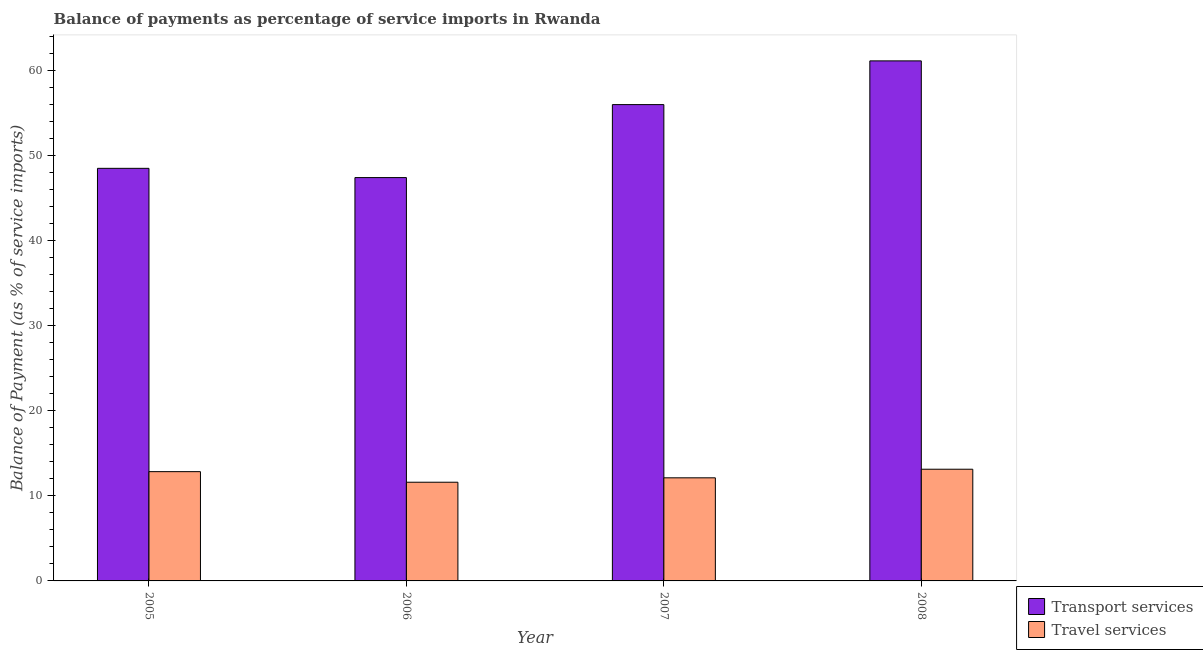How many groups of bars are there?
Ensure brevity in your answer.  4. Are the number of bars per tick equal to the number of legend labels?
Keep it short and to the point. Yes. Are the number of bars on each tick of the X-axis equal?
Give a very brief answer. Yes. How many bars are there on the 3rd tick from the right?
Ensure brevity in your answer.  2. In how many cases, is the number of bars for a given year not equal to the number of legend labels?
Make the answer very short. 0. What is the balance of payments of transport services in 2007?
Offer a terse response. 55.98. Across all years, what is the maximum balance of payments of transport services?
Offer a terse response. 61.11. Across all years, what is the minimum balance of payments of transport services?
Keep it short and to the point. 47.4. In which year was the balance of payments of transport services minimum?
Make the answer very short. 2006. What is the total balance of payments of transport services in the graph?
Offer a terse response. 212.97. What is the difference between the balance of payments of transport services in 2006 and that in 2007?
Your answer should be very brief. -8.58. What is the difference between the balance of payments of transport services in 2005 and the balance of payments of travel services in 2008?
Your answer should be compact. -12.63. What is the average balance of payments of travel services per year?
Provide a succinct answer. 12.42. In how many years, is the balance of payments of travel services greater than 20 %?
Provide a succinct answer. 0. What is the ratio of the balance of payments of transport services in 2005 to that in 2008?
Provide a short and direct response. 0.79. What is the difference between the highest and the second highest balance of payments of transport services?
Offer a terse response. 5.14. What is the difference between the highest and the lowest balance of payments of travel services?
Ensure brevity in your answer.  1.53. What does the 1st bar from the left in 2006 represents?
Make the answer very short. Transport services. What does the 1st bar from the right in 2007 represents?
Your answer should be compact. Travel services. What is the difference between two consecutive major ticks on the Y-axis?
Your answer should be compact. 10. Are the values on the major ticks of Y-axis written in scientific E-notation?
Give a very brief answer. No. What is the title of the graph?
Your answer should be compact. Balance of payments as percentage of service imports in Rwanda. Does "Revenue" appear as one of the legend labels in the graph?
Provide a succinct answer. No. What is the label or title of the X-axis?
Give a very brief answer. Year. What is the label or title of the Y-axis?
Provide a succinct answer. Balance of Payment (as % of service imports). What is the Balance of Payment (as % of service imports) of Transport services in 2005?
Ensure brevity in your answer.  48.49. What is the Balance of Payment (as % of service imports) of Travel services in 2005?
Your response must be concise. 12.84. What is the Balance of Payment (as % of service imports) in Transport services in 2006?
Give a very brief answer. 47.4. What is the Balance of Payment (as % of service imports) in Travel services in 2006?
Your response must be concise. 11.6. What is the Balance of Payment (as % of service imports) in Transport services in 2007?
Offer a terse response. 55.98. What is the Balance of Payment (as % of service imports) of Travel services in 2007?
Provide a short and direct response. 12.12. What is the Balance of Payment (as % of service imports) of Transport services in 2008?
Offer a very short reply. 61.11. What is the Balance of Payment (as % of service imports) of Travel services in 2008?
Your answer should be compact. 13.13. Across all years, what is the maximum Balance of Payment (as % of service imports) of Transport services?
Make the answer very short. 61.11. Across all years, what is the maximum Balance of Payment (as % of service imports) of Travel services?
Provide a succinct answer. 13.13. Across all years, what is the minimum Balance of Payment (as % of service imports) in Transport services?
Provide a succinct answer. 47.4. Across all years, what is the minimum Balance of Payment (as % of service imports) of Travel services?
Offer a terse response. 11.6. What is the total Balance of Payment (as % of service imports) of Transport services in the graph?
Keep it short and to the point. 212.97. What is the total Balance of Payment (as % of service imports) of Travel services in the graph?
Offer a very short reply. 49.68. What is the difference between the Balance of Payment (as % of service imports) in Transport services in 2005 and that in 2006?
Provide a short and direct response. 1.09. What is the difference between the Balance of Payment (as % of service imports) in Travel services in 2005 and that in 2006?
Make the answer very short. 1.24. What is the difference between the Balance of Payment (as % of service imports) of Transport services in 2005 and that in 2007?
Your response must be concise. -7.49. What is the difference between the Balance of Payment (as % of service imports) of Travel services in 2005 and that in 2007?
Make the answer very short. 0.73. What is the difference between the Balance of Payment (as % of service imports) of Transport services in 2005 and that in 2008?
Offer a very short reply. -12.63. What is the difference between the Balance of Payment (as % of service imports) in Travel services in 2005 and that in 2008?
Your answer should be compact. -0.28. What is the difference between the Balance of Payment (as % of service imports) of Transport services in 2006 and that in 2007?
Your answer should be compact. -8.58. What is the difference between the Balance of Payment (as % of service imports) of Travel services in 2006 and that in 2007?
Ensure brevity in your answer.  -0.52. What is the difference between the Balance of Payment (as % of service imports) in Transport services in 2006 and that in 2008?
Ensure brevity in your answer.  -13.72. What is the difference between the Balance of Payment (as % of service imports) in Travel services in 2006 and that in 2008?
Your answer should be compact. -1.53. What is the difference between the Balance of Payment (as % of service imports) of Transport services in 2007 and that in 2008?
Give a very brief answer. -5.14. What is the difference between the Balance of Payment (as % of service imports) in Travel services in 2007 and that in 2008?
Ensure brevity in your answer.  -1.01. What is the difference between the Balance of Payment (as % of service imports) of Transport services in 2005 and the Balance of Payment (as % of service imports) of Travel services in 2006?
Your answer should be compact. 36.89. What is the difference between the Balance of Payment (as % of service imports) in Transport services in 2005 and the Balance of Payment (as % of service imports) in Travel services in 2007?
Provide a succinct answer. 36.37. What is the difference between the Balance of Payment (as % of service imports) in Transport services in 2005 and the Balance of Payment (as % of service imports) in Travel services in 2008?
Provide a succinct answer. 35.36. What is the difference between the Balance of Payment (as % of service imports) of Transport services in 2006 and the Balance of Payment (as % of service imports) of Travel services in 2007?
Your response must be concise. 35.28. What is the difference between the Balance of Payment (as % of service imports) of Transport services in 2006 and the Balance of Payment (as % of service imports) of Travel services in 2008?
Keep it short and to the point. 34.27. What is the difference between the Balance of Payment (as % of service imports) of Transport services in 2007 and the Balance of Payment (as % of service imports) of Travel services in 2008?
Offer a very short reply. 42.85. What is the average Balance of Payment (as % of service imports) in Transport services per year?
Give a very brief answer. 53.24. What is the average Balance of Payment (as % of service imports) in Travel services per year?
Ensure brevity in your answer.  12.42. In the year 2005, what is the difference between the Balance of Payment (as % of service imports) of Transport services and Balance of Payment (as % of service imports) of Travel services?
Provide a short and direct response. 35.64. In the year 2006, what is the difference between the Balance of Payment (as % of service imports) in Transport services and Balance of Payment (as % of service imports) in Travel services?
Provide a short and direct response. 35.8. In the year 2007, what is the difference between the Balance of Payment (as % of service imports) in Transport services and Balance of Payment (as % of service imports) in Travel services?
Your answer should be compact. 43.86. In the year 2008, what is the difference between the Balance of Payment (as % of service imports) of Transport services and Balance of Payment (as % of service imports) of Travel services?
Offer a terse response. 47.99. What is the ratio of the Balance of Payment (as % of service imports) in Transport services in 2005 to that in 2006?
Make the answer very short. 1.02. What is the ratio of the Balance of Payment (as % of service imports) of Travel services in 2005 to that in 2006?
Give a very brief answer. 1.11. What is the ratio of the Balance of Payment (as % of service imports) of Transport services in 2005 to that in 2007?
Your answer should be compact. 0.87. What is the ratio of the Balance of Payment (as % of service imports) of Travel services in 2005 to that in 2007?
Your answer should be very brief. 1.06. What is the ratio of the Balance of Payment (as % of service imports) in Transport services in 2005 to that in 2008?
Offer a terse response. 0.79. What is the ratio of the Balance of Payment (as % of service imports) in Travel services in 2005 to that in 2008?
Ensure brevity in your answer.  0.98. What is the ratio of the Balance of Payment (as % of service imports) of Transport services in 2006 to that in 2007?
Your response must be concise. 0.85. What is the ratio of the Balance of Payment (as % of service imports) in Travel services in 2006 to that in 2007?
Give a very brief answer. 0.96. What is the ratio of the Balance of Payment (as % of service imports) of Transport services in 2006 to that in 2008?
Give a very brief answer. 0.78. What is the ratio of the Balance of Payment (as % of service imports) of Travel services in 2006 to that in 2008?
Make the answer very short. 0.88. What is the ratio of the Balance of Payment (as % of service imports) of Transport services in 2007 to that in 2008?
Make the answer very short. 0.92. What is the ratio of the Balance of Payment (as % of service imports) of Travel services in 2007 to that in 2008?
Provide a succinct answer. 0.92. What is the difference between the highest and the second highest Balance of Payment (as % of service imports) in Transport services?
Give a very brief answer. 5.14. What is the difference between the highest and the second highest Balance of Payment (as % of service imports) in Travel services?
Ensure brevity in your answer.  0.28. What is the difference between the highest and the lowest Balance of Payment (as % of service imports) of Transport services?
Keep it short and to the point. 13.72. What is the difference between the highest and the lowest Balance of Payment (as % of service imports) of Travel services?
Keep it short and to the point. 1.53. 